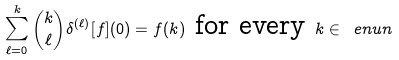Convert formula to latex. <formula><loc_0><loc_0><loc_500><loc_500>\sum _ { \ell = 0 } ^ { k } \binom { k } { \ell } \delta ^ { ( \ell ) } [ f ] ( 0 ) = f ( k ) \text { for every } k \in \ e n u { n }</formula> 